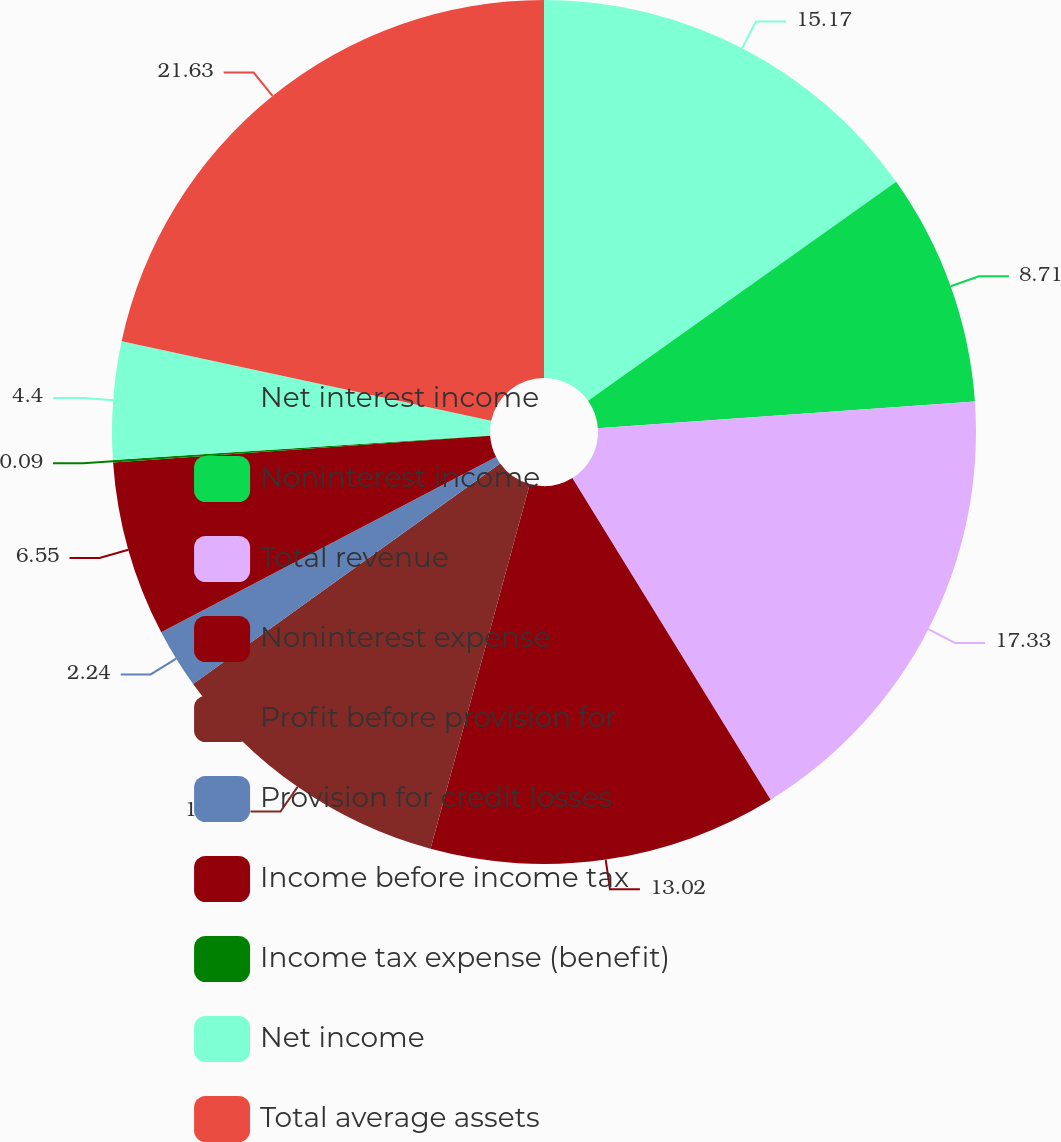<chart> <loc_0><loc_0><loc_500><loc_500><pie_chart><fcel>Net interest income<fcel>Noninterest income<fcel>Total revenue<fcel>Noninterest expense<fcel>Profit before provision for<fcel>Provision for credit losses<fcel>Income before income tax<fcel>Income tax expense (benefit)<fcel>Net income<fcel>Total average assets<nl><fcel>15.17%<fcel>8.71%<fcel>17.33%<fcel>13.02%<fcel>10.86%<fcel>2.24%<fcel>6.55%<fcel>0.09%<fcel>4.4%<fcel>21.63%<nl></chart> 